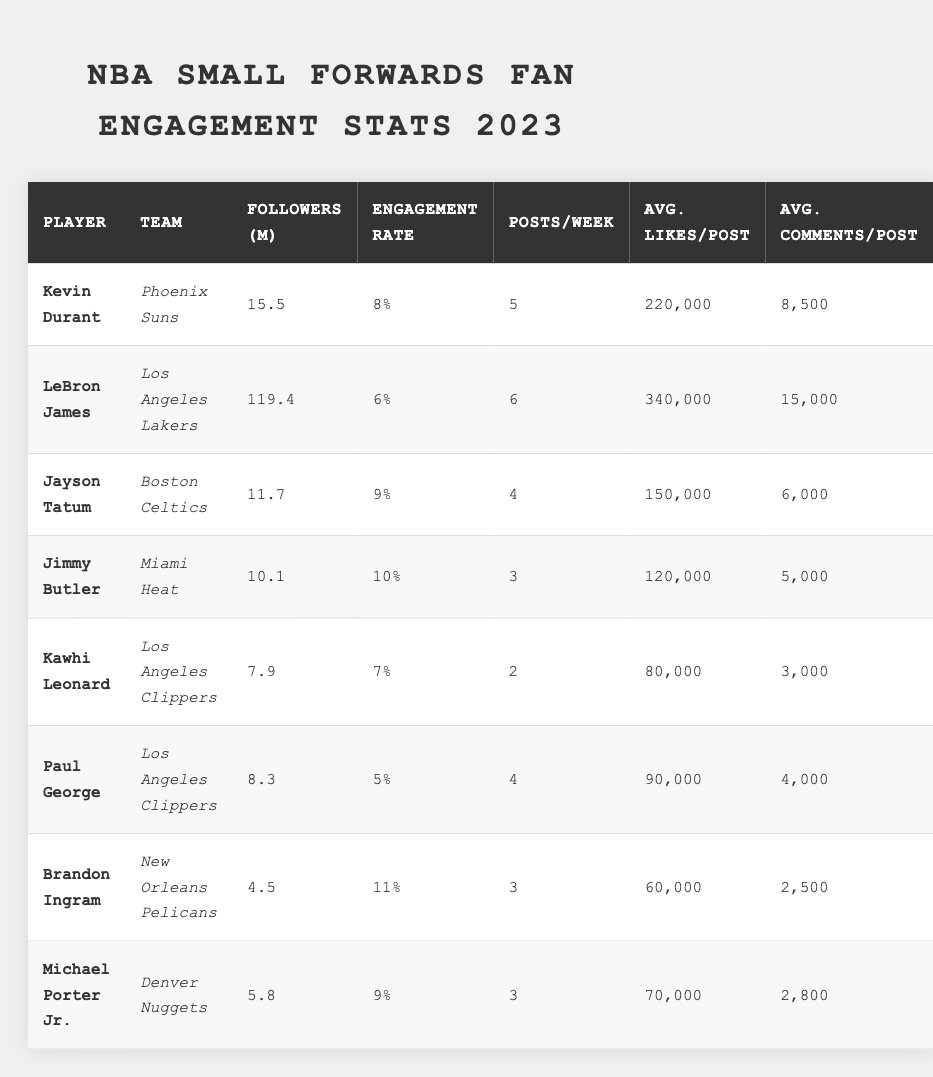What is the player with the highest number of followers in the table? By scanning the 'Followers (M)' column, LeBron James has the highest follower count of 119.4 million.
Answer: LeBron James Which player has the highest engagement rate? Looking at the 'Engagement Rate' column, Jimmy Butler has the highest engagement rate at 10%.
Answer: Jimmy Butler How many average likes per post does Kevin Durant receive? In the 'Avg. Likes/Post' column, Kevin Durant has an average of 220,000 likes per post.
Answer: 220,000 What is the total number of average comments per post for all players combined? The total can be calculated by summing up the 'Avg. Comments/Post' values: 8,500 + 15,000 + 6,000 + 5,000 + 3,000 + 4,000 + 2,500 + 2,800 = 47,800.
Answer: 47,800 Does Kawhi Leonard have a higher engagement rate than Paul George? In the table, Kawhi Leonard has an engagement rate of 7% while Paul George has 5%, so Kawhi's engagement rate is higher.
Answer: Yes Which player posts the most frequently and what is that frequency? By looking through the 'Posts/Week' column, LeBron James posts the most frequently, with 6 posts per week.
Answer: 6 posts per week What is the average number of posts per week for all players combined? To find the average, sum the posts (5 + 6 + 4 + 3 + 2 + 4 + 3 + 3 = 30) and divide by the number of players (8): 30/8 = 3.75.
Answer: 3.75 Is Jimmy Butler more engaged than Kevin Durant based on engagement rates? Looking at the engagement rates, Jimmy Butler has 10% while Kevin Durant has 8%, showing that Jimmy is more engaged.
Answer: Yes Calculate the difference in average comments per post between Brandon Ingram and Jayson Tatum. For Brandon Ingram, the average comments per post is 2,500; for Jayson Tatum, it's 6,000. The difference is 6,000 - 2,500 = 3,500.
Answer: 3,500 Who has the least followers among the players? Scanning the 'Followers (M)' column, Brandon Ingram has the least number of followers at 4.5 million.
Answer: Brandon Ingram 